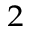Convert formula to latex. <formula><loc_0><loc_0><loc_500><loc_500>^ { 2 }</formula> 